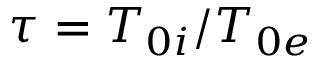<formula> <loc_0><loc_0><loc_500><loc_500>\tau = T _ { 0 i } / T _ { 0 e }</formula> 